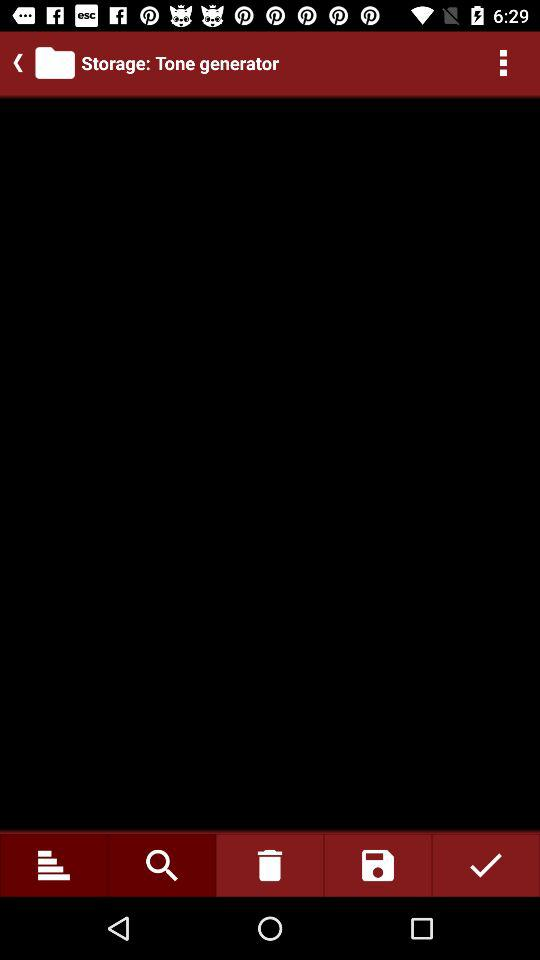What is the application name? The application name is "Tone generator". 